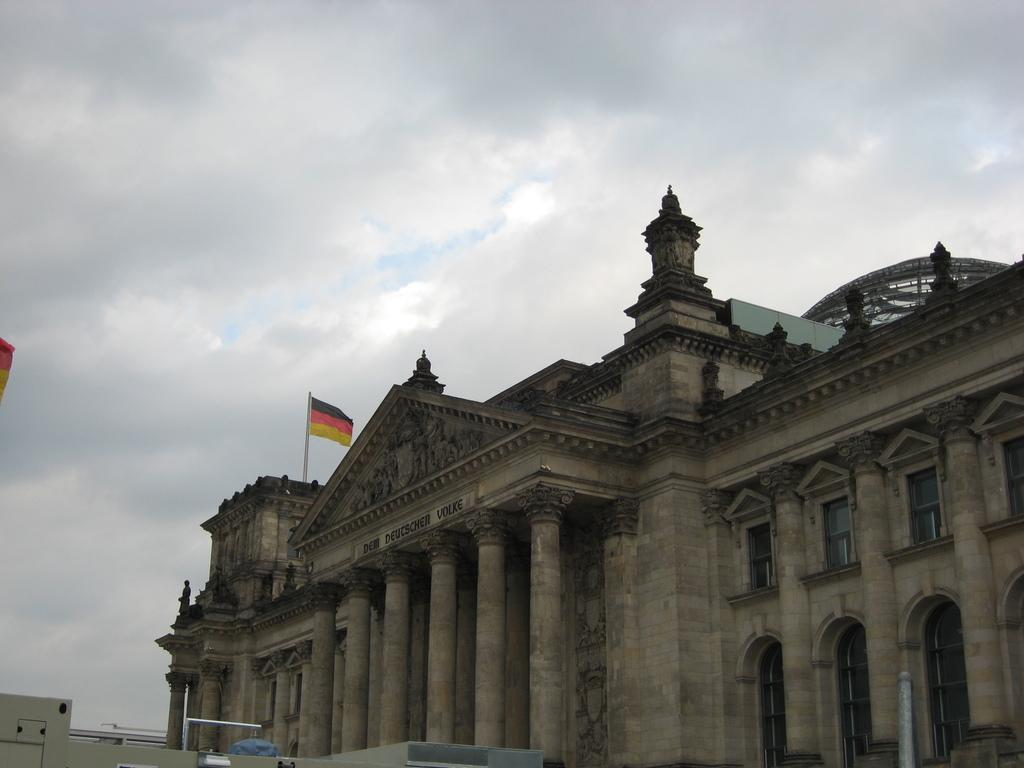What is the main subject of the image? The image depicts a monument. Is there any symbol or object on the monument? Yes, there is a flag on the monument. How would you describe the weather in the image? The sky is cloudy in the image. What type of hat is the monument wearing in the image? The monument is not wearing a hat; it is a structure and does not have clothing or accessories. 